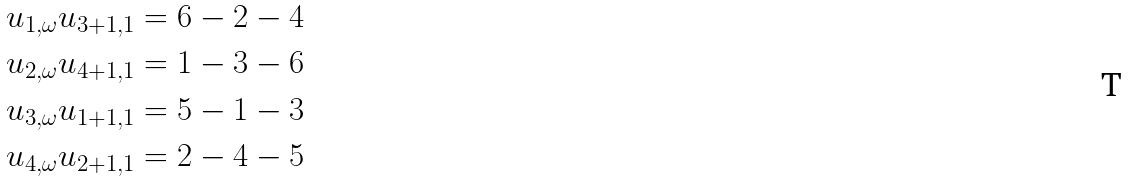Convert formula to latex. <formula><loc_0><loc_0><loc_500><loc_500>u _ { 1 , \omega } u _ { 3 + 1 , 1 } & = 6 - 2 - 4 \\ u _ { 2 , \omega } u _ { 4 + 1 , 1 } & = 1 - 3 - 6 \\ u _ { 3 , \omega } u _ { 1 + 1 , 1 } & = 5 - 1 - 3 \\ u _ { 4 , \omega } u _ { 2 + 1 , 1 } & = 2 - 4 - 5</formula> 